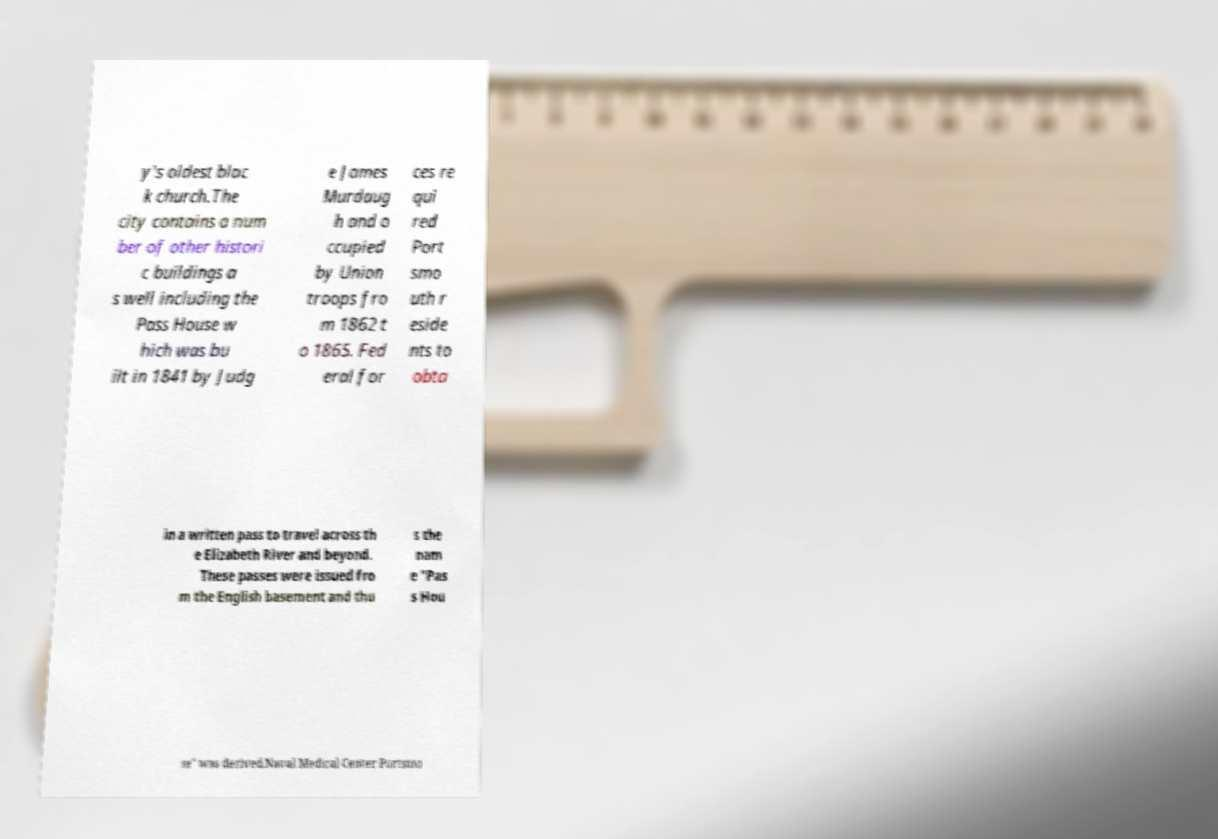Please read and relay the text visible in this image. What does it say? y's oldest blac k church.The city contains a num ber of other histori c buildings a s well including the Pass House w hich was bu ilt in 1841 by Judg e James Murdaug h and o ccupied by Union troops fro m 1862 t o 1865. Fed eral for ces re qui red Port smo uth r eside nts to obta in a written pass to travel across th e Elizabeth River and beyond. These passes were issued fro m the English basement and thu s the nam e "Pas s Hou se" was derived.Naval Medical Center Portsmo 